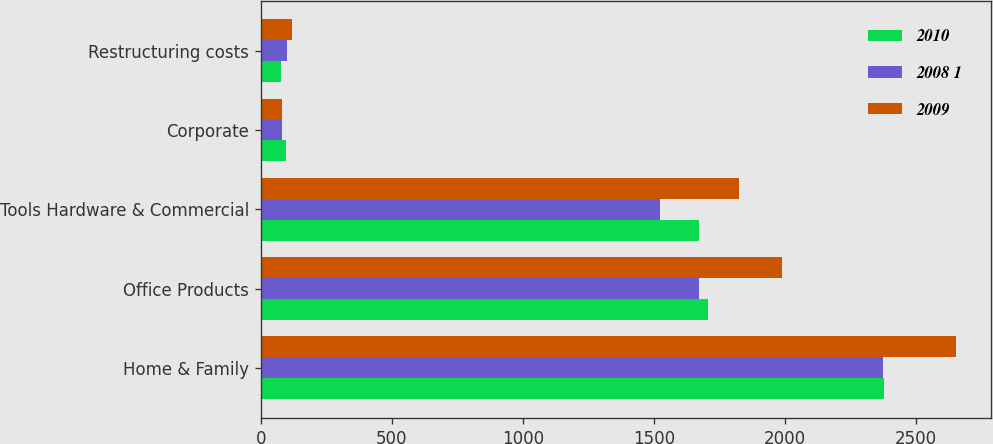<chart> <loc_0><loc_0><loc_500><loc_500><stacked_bar_chart><ecel><fcel>Home & Family<fcel>Office Products<fcel>Tools Hardware & Commercial<fcel>Corporate<fcel>Restructuring costs<nl><fcel>2010<fcel>2378.4<fcel>1708.9<fcel>1671.9<fcel>96.9<fcel>77.5<nl><fcel>2008 1<fcel>2377.2<fcel>1674.7<fcel>1525.7<fcel>80.6<fcel>100<nl><fcel>2009<fcel>2654.8<fcel>1990.8<fcel>1825<fcel>81.9<fcel>120.3<nl></chart> 